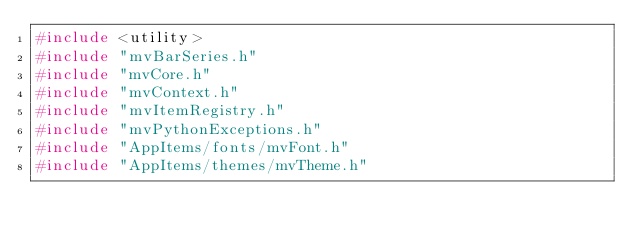Convert code to text. <code><loc_0><loc_0><loc_500><loc_500><_C++_>#include <utility>
#include "mvBarSeries.h"
#include "mvCore.h"
#include "mvContext.h"
#include "mvItemRegistry.h"
#include "mvPythonExceptions.h"
#include "AppItems/fonts/mvFont.h"
#include "AppItems/themes/mvTheme.h"</code> 